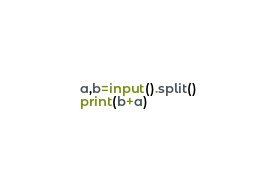Convert code to text. <code><loc_0><loc_0><loc_500><loc_500><_Python_>a,b=input().split()
print(b+a)
</code> 